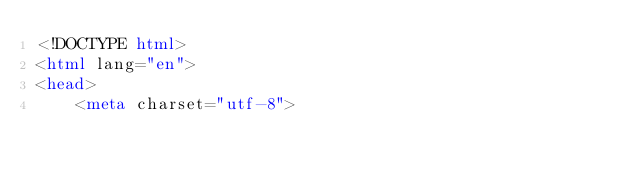Convert code to text. <code><loc_0><loc_0><loc_500><loc_500><_HTML_><!DOCTYPE html>
<html lang="en">
<head>
    <meta charset="utf-8"></code> 